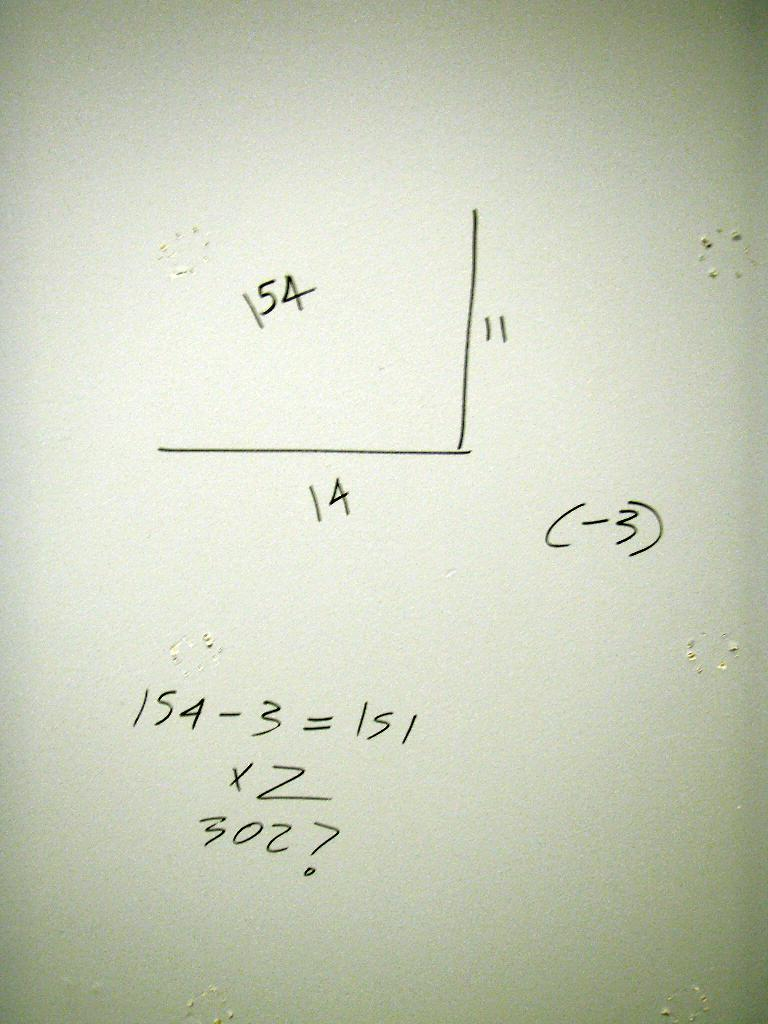<image>
Create a compact narrative representing the image presented. Two lines meeting on the right edge has a 14 on bottom and 11 on the side. 